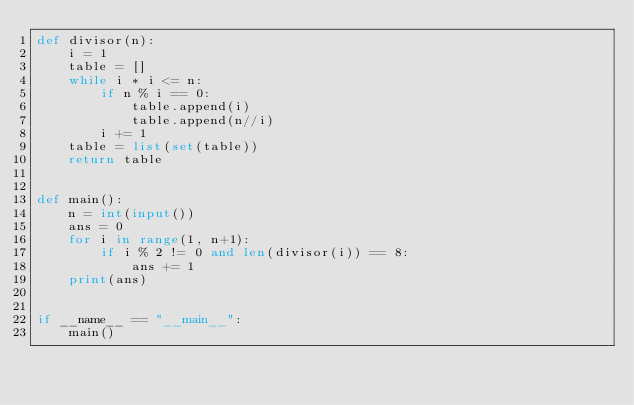<code> <loc_0><loc_0><loc_500><loc_500><_Python_>def divisor(n):
    i = 1
    table = []
    while i * i <= n:
        if n % i == 0:
            table.append(i)
            table.append(n//i)
        i += 1
    table = list(set(table))
    return table


def main():
    n = int(input())
    ans = 0
    for i in range(1, n+1):
        if i % 2 != 0 and len(divisor(i)) == 8:
            ans += 1
    print(ans)


if __name__ == "__main__":
    main()
</code> 